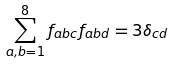<formula> <loc_0><loc_0><loc_500><loc_500>\sum _ { a , b = 1 } ^ { 8 } f _ { a b c } f _ { a b d } = 3 \delta _ { c d }</formula> 